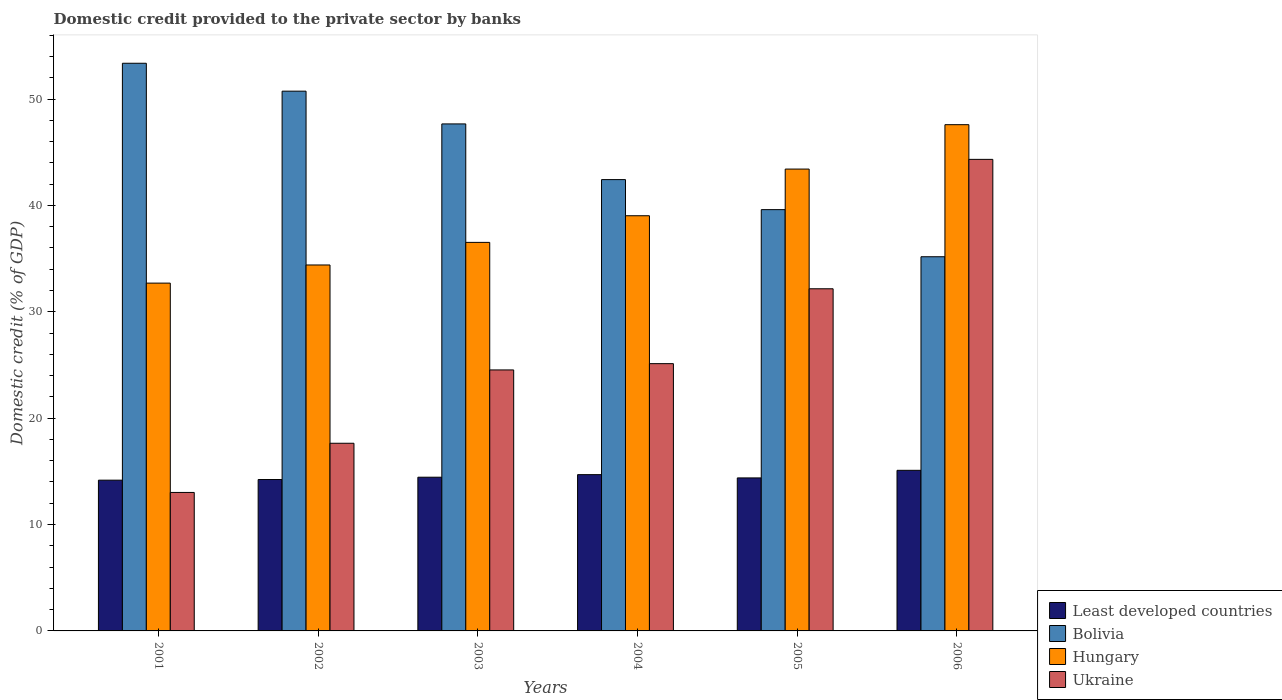How many different coloured bars are there?
Give a very brief answer. 4. How many groups of bars are there?
Make the answer very short. 6. Are the number of bars on each tick of the X-axis equal?
Ensure brevity in your answer.  Yes. What is the label of the 2nd group of bars from the left?
Make the answer very short. 2002. What is the domestic credit provided to the private sector by banks in Ukraine in 2005?
Provide a succinct answer. 32.16. Across all years, what is the maximum domestic credit provided to the private sector by banks in Hungary?
Offer a very short reply. 47.59. Across all years, what is the minimum domestic credit provided to the private sector by banks in Bolivia?
Your answer should be very brief. 35.17. What is the total domestic credit provided to the private sector by banks in Least developed countries in the graph?
Offer a very short reply. 87.03. What is the difference between the domestic credit provided to the private sector by banks in Ukraine in 2004 and that in 2006?
Provide a short and direct response. -19.2. What is the difference between the domestic credit provided to the private sector by banks in Hungary in 2001 and the domestic credit provided to the private sector by banks in Ukraine in 2006?
Give a very brief answer. -11.63. What is the average domestic credit provided to the private sector by banks in Least developed countries per year?
Provide a short and direct response. 14.5. In the year 2004, what is the difference between the domestic credit provided to the private sector by banks in Least developed countries and domestic credit provided to the private sector by banks in Hungary?
Offer a terse response. -24.34. What is the ratio of the domestic credit provided to the private sector by banks in Ukraine in 2002 to that in 2006?
Your answer should be compact. 0.4. What is the difference between the highest and the second highest domestic credit provided to the private sector by banks in Bolivia?
Keep it short and to the point. 2.62. What is the difference between the highest and the lowest domestic credit provided to the private sector by banks in Least developed countries?
Offer a very short reply. 0.93. In how many years, is the domestic credit provided to the private sector by banks in Least developed countries greater than the average domestic credit provided to the private sector by banks in Least developed countries taken over all years?
Give a very brief answer. 2. Is the sum of the domestic credit provided to the private sector by banks in Hungary in 2001 and 2005 greater than the maximum domestic credit provided to the private sector by banks in Least developed countries across all years?
Your response must be concise. Yes. What does the 1st bar from the right in 2004 represents?
Provide a short and direct response. Ukraine. Are all the bars in the graph horizontal?
Your answer should be compact. No. How many years are there in the graph?
Offer a terse response. 6. What is the difference between two consecutive major ticks on the Y-axis?
Ensure brevity in your answer.  10. Does the graph contain any zero values?
Provide a succinct answer. No. Does the graph contain grids?
Keep it short and to the point. No. How many legend labels are there?
Your answer should be compact. 4. What is the title of the graph?
Make the answer very short. Domestic credit provided to the private sector by banks. Does "Dominica" appear as one of the legend labels in the graph?
Give a very brief answer. No. What is the label or title of the Y-axis?
Your response must be concise. Domestic credit (% of GDP). What is the Domestic credit (% of GDP) in Least developed countries in 2001?
Offer a terse response. 14.17. What is the Domestic credit (% of GDP) of Bolivia in 2001?
Your answer should be compact. 53.36. What is the Domestic credit (% of GDP) of Hungary in 2001?
Keep it short and to the point. 32.7. What is the Domestic credit (% of GDP) of Ukraine in 2001?
Ensure brevity in your answer.  13.02. What is the Domestic credit (% of GDP) in Least developed countries in 2002?
Make the answer very short. 14.23. What is the Domestic credit (% of GDP) in Bolivia in 2002?
Give a very brief answer. 50.74. What is the Domestic credit (% of GDP) of Hungary in 2002?
Your answer should be very brief. 34.4. What is the Domestic credit (% of GDP) in Ukraine in 2002?
Your response must be concise. 17.64. What is the Domestic credit (% of GDP) of Least developed countries in 2003?
Give a very brief answer. 14.45. What is the Domestic credit (% of GDP) in Bolivia in 2003?
Keep it short and to the point. 47.66. What is the Domestic credit (% of GDP) in Hungary in 2003?
Ensure brevity in your answer.  36.52. What is the Domestic credit (% of GDP) in Ukraine in 2003?
Provide a succinct answer. 24.54. What is the Domestic credit (% of GDP) of Least developed countries in 2004?
Offer a terse response. 14.69. What is the Domestic credit (% of GDP) of Bolivia in 2004?
Provide a short and direct response. 42.43. What is the Domestic credit (% of GDP) in Hungary in 2004?
Ensure brevity in your answer.  39.03. What is the Domestic credit (% of GDP) in Ukraine in 2004?
Give a very brief answer. 25.13. What is the Domestic credit (% of GDP) of Least developed countries in 2005?
Your answer should be very brief. 14.38. What is the Domestic credit (% of GDP) in Bolivia in 2005?
Your response must be concise. 39.6. What is the Domestic credit (% of GDP) in Hungary in 2005?
Provide a succinct answer. 43.42. What is the Domestic credit (% of GDP) of Ukraine in 2005?
Provide a short and direct response. 32.16. What is the Domestic credit (% of GDP) in Least developed countries in 2006?
Ensure brevity in your answer.  15.1. What is the Domestic credit (% of GDP) of Bolivia in 2006?
Your response must be concise. 35.17. What is the Domestic credit (% of GDP) of Hungary in 2006?
Offer a terse response. 47.59. What is the Domestic credit (% of GDP) of Ukraine in 2006?
Provide a short and direct response. 44.33. Across all years, what is the maximum Domestic credit (% of GDP) of Least developed countries?
Your answer should be compact. 15.1. Across all years, what is the maximum Domestic credit (% of GDP) of Bolivia?
Provide a succinct answer. 53.36. Across all years, what is the maximum Domestic credit (% of GDP) in Hungary?
Your response must be concise. 47.59. Across all years, what is the maximum Domestic credit (% of GDP) in Ukraine?
Your answer should be compact. 44.33. Across all years, what is the minimum Domestic credit (% of GDP) in Least developed countries?
Your answer should be compact. 14.17. Across all years, what is the minimum Domestic credit (% of GDP) in Bolivia?
Keep it short and to the point. 35.17. Across all years, what is the minimum Domestic credit (% of GDP) of Hungary?
Your answer should be very brief. 32.7. Across all years, what is the minimum Domestic credit (% of GDP) of Ukraine?
Make the answer very short. 13.02. What is the total Domestic credit (% of GDP) of Least developed countries in the graph?
Your answer should be compact. 87.03. What is the total Domestic credit (% of GDP) in Bolivia in the graph?
Offer a terse response. 268.97. What is the total Domestic credit (% of GDP) of Hungary in the graph?
Give a very brief answer. 233.66. What is the total Domestic credit (% of GDP) of Ukraine in the graph?
Your answer should be compact. 156.81. What is the difference between the Domestic credit (% of GDP) in Least developed countries in 2001 and that in 2002?
Make the answer very short. -0.06. What is the difference between the Domestic credit (% of GDP) of Bolivia in 2001 and that in 2002?
Your answer should be very brief. 2.62. What is the difference between the Domestic credit (% of GDP) of Hungary in 2001 and that in 2002?
Your answer should be very brief. -1.71. What is the difference between the Domestic credit (% of GDP) of Ukraine in 2001 and that in 2002?
Keep it short and to the point. -4.62. What is the difference between the Domestic credit (% of GDP) of Least developed countries in 2001 and that in 2003?
Provide a short and direct response. -0.28. What is the difference between the Domestic credit (% of GDP) in Bolivia in 2001 and that in 2003?
Offer a very short reply. 5.7. What is the difference between the Domestic credit (% of GDP) of Hungary in 2001 and that in 2003?
Provide a short and direct response. -3.83. What is the difference between the Domestic credit (% of GDP) of Ukraine in 2001 and that in 2003?
Provide a succinct answer. -11.52. What is the difference between the Domestic credit (% of GDP) in Least developed countries in 2001 and that in 2004?
Provide a succinct answer. -0.52. What is the difference between the Domestic credit (% of GDP) in Bolivia in 2001 and that in 2004?
Provide a short and direct response. 10.94. What is the difference between the Domestic credit (% of GDP) in Hungary in 2001 and that in 2004?
Offer a very short reply. -6.33. What is the difference between the Domestic credit (% of GDP) of Ukraine in 2001 and that in 2004?
Provide a succinct answer. -12.11. What is the difference between the Domestic credit (% of GDP) of Least developed countries in 2001 and that in 2005?
Provide a succinct answer. -0.21. What is the difference between the Domestic credit (% of GDP) of Bolivia in 2001 and that in 2005?
Give a very brief answer. 13.76. What is the difference between the Domestic credit (% of GDP) of Hungary in 2001 and that in 2005?
Your response must be concise. -10.72. What is the difference between the Domestic credit (% of GDP) in Ukraine in 2001 and that in 2005?
Offer a terse response. -19.15. What is the difference between the Domestic credit (% of GDP) of Least developed countries in 2001 and that in 2006?
Ensure brevity in your answer.  -0.93. What is the difference between the Domestic credit (% of GDP) in Bolivia in 2001 and that in 2006?
Give a very brief answer. 18.19. What is the difference between the Domestic credit (% of GDP) in Hungary in 2001 and that in 2006?
Offer a very short reply. -14.89. What is the difference between the Domestic credit (% of GDP) in Ukraine in 2001 and that in 2006?
Your answer should be compact. -31.31. What is the difference between the Domestic credit (% of GDP) of Least developed countries in 2002 and that in 2003?
Ensure brevity in your answer.  -0.22. What is the difference between the Domestic credit (% of GDP) of Bolivia in 2002 and that in 2003?
Provide a succinct answer. 3.08. What is the difference between the Domestic credit (% of GDP) of Hungary in 2002 and that in 2003?
Ensure brevity in your answer.  -2.12. What is the difference between the Domestic credit (% of GDP) of Ukraine in 2002 and that in 2003?
Your answer should be very brief. -6.89. What is the difference between the Domestic credit (% of GDP) in Least developed countries in 2002 and that in 2004?
Keep it short and to the point. -0.46. What is the difference between the Domestic credit (% of GDP) in Bolivia in 2002 and that in 2004?
Your answer should be very brief. 8.31. What is the difference between the Domestic credit (% of GDP) of Hungary in 2002 and that in 2004?
Provide a short and direct response. -4.63. What is the difference between the Domestic credit (% of GDP) in Ukraine in 2002 and that in 2004?
Give a very brief answer. -7.48. What is the difference between the Domestic credit (% of GDP) in Least developed countries in 2002 and that in 2005?
Keep it short and to the point. -0.15. What is the difference between the Domestic credit (% of GDP) in Bolivia in 2002 and that in 2005?
Give a very brief answer. 11.14. What is the difference between the Domestic credit (% of GDP) of Hungary in 2002 and that in 2005?
Make the answer very short. -9.02. What is the difference between the Domestic credit (% of GDP) in Ukraine in 2002 and that in 2005?
Your answer should be very brief. -14.52. What is the difference between the Domestic credit (% of GDP) of Least developed countries in 2002 and that in 2006?
Offer a very short reply. -0.86. What is the difference between the Domestic credit (% of GDP) in Bolivia in 2002 and that in 2006?
Provide a short and direct response. 15.57. What is the difference between the Domestic credit (% of GDP) of Hungary in 2002 and that in 2006?
Provide a succinct answer. -13.19. What is the difference between the Domestic credit (% of GDP) in Ukraine in 2002 and that in 2006?
Give a very brief answer. -26.69. What is the difference between the Domestic credit (% of GDP) in Least developed countries in 2003 and that in 2004?
Provide a short and direct response. -0.24. What is the difference between the Domestic credit (% of GDP) of Bolivia in 2003 and that in 2004?
Provide a succinct answer. 5.23. What is the difference between the Domestic credit (% of GDP) of Hungary in 2003 and that in 2004?
Ensure brevity in your answer.  -2.5. What is the difference between the Domestic credit (% of GDP) in Ukraine in 2003 and that in 2004?
Provide a short and direct response. -0.59. What is the difference between the Domestic credit (% of GDP) of Least developed countries in 2003 and that in 2005?
Make the answer very short. 0.07. What is the difference between the Domestic credit (% of GDP) in Bolivia in 2003 and that in 2005?
Keep it short and to the point. 8.06. What is the difference between the Domestic credit (% of GDP) in Hungary in 2003 and that in 2005?
Offer a terse response. -6.89. What is the difference between the Domestic credit (% of GDP) of Ukraine in 2003 and that in 2005?
Keep it short and to the point. -7.63. What is the difference between the Domestic credit (% of GDP) in Least developed countries in 2003 and that in 2006?
Offer a terse response. -0.65. What is the difference between the Domestic credit (% of GDP) of Bolivia in 2003 and that in 2006?
Your answer should be compact. 12.49. What is the difference between the Domestic credit (% of GDP) of Hungary in 2003 and that in 2006?
Offer a terse response. -11.07. What is the difference between the Domestic credit (% of GDP) of Ukraine in 2003 and that in 2006?
Give a very brief answer. -19.79. What is the difference between the Domestic credit (% of GDP) of Least developed countries in 2004 and that in 2005?
Make the answer very short. 0.31. What is the difference between the Domestic credit (% of GDP) of Bolivia in 2004 and that in 2005?
Offer a terse response. 2.82. What is the difference between the Domestic credit (% of GDP) in Hungary in 2004 and that in 2005?
Provide a succinct answer. -4.39. What is the difference between the Domestic credit (% of GDP) in Ukraine in 2004 and that in 2005?
Your answer should be very brief. -7.04. What is the difference between the Domestic credit (% of GDP) of Least developed countries in 2004 and that in 2006?
Provide a short and direct response. -0.41. What is the difference between the Domestic credit (% of GDP) in Bolivia in 2004 and that in 2006?
Offer a very short reply. 7.25. What is the difference between the Domestic credit (% of GDP) in Hungary in 2004 and that in 2006?
Provide a succinct answer. -8.56. What is the difference between the Domestic credit (% of GDP) of Ukraine in 2004 and that in 2006?
Your response must be concise. -19.2. What is the difference between the Domestic credit (% of GDP) in Least developed countries in 2005 and that in 2006?
Your answer should be compact. -0.71. What is the difference between the Domestic credit (% of GDP) of Bolivia in 2005 and that in 2006?
Ensure brevity in your answer.  4.43. What is the difference between the Domestic credit (% of GDP) of Hungary in 2005 and that in 2006?
Provide a succinct answer. -4.17. What is the difference between the Domestic credit (% of GDP) in Ukraine in 2005 and that in 2006?
Ensure brevity in your answer.  -12.17. What is the difference between the Domestic credit (% of GDP) of Least developed countries in 2001 and the Domestic credit (% of GDP) of Bolivia in 2002?
Give a very brief answer. -36.57. What is the difference between the Domestic credit (% of GDP) of Least developed countries in 2001 and the Domestic credit (% of GDP) of Hungary in 2002?
Offer a terse response. -20.23. What is the difference between the Domestic credit (% of GDP) in Least developed countries in 2001 and the Domestic credit (% of GDP) in Ukraine in 2002?
Your answer should be very brief. -3.47. What is the difference between the Domestic credit (% of GDP) of Bolivia in 2001 and the Domestic credit (% of GDP) of Hungary in 2002?
Offer a terse response. 18.96. What is the difference between the Domestic credit (% of GDP) in Bolivia in 2001 and the Domestic credit (% of GDP) in Ukraine in 2002?
Provide a short and direct response. 35.72. What is the difference between the Domestic credit (% of GDP) in Hungary in 2001 and the Domestic credit (% of GDP) in Ukraine in 2002?
Keep it short and to the point. 15.05. What is the difference between the Domestic credit (% of GDP) of Least developed countries in 2001 and the Domestic credit (% of GDP) of Bolivia in 2003?
Your answer should be very brief. -33.49. What is the difference between the Domestic credit (% of GDP) of Least developed countries in 2001 and the Domestic credit (% of GDP) of Hungary in 2003?
Provide a succinct answer. -22.35. What is the difference between the Domestic credit (% of GDP) in Least developed countries in 2001 and the Domestic credit (% of GDP) in Ukraine in 2003?
Offer a very short reply. -10.36. What is the difference between the Domestic credit (% of GDP) of Bolivia in 2001 and the Domestic credit (% of GDP) of Hungary in 2003?
Your answer should be very brief. 16.84. What is the difference between the Domestic credit (% of GDP) of Bolivia in 2001 and the Domestic credit (% of GDP) of Ukraine in 2003?
Provide a short and direct response. 28.83. What is the difference between the Domestic credit (% of GDP) of Hungary in 2001 and the Domestic credit (% of GDP) of Ukraine in 2003?
Your answer should be compact. 8.16. What is the difference between the Domestic credit (% of GDP) of Least developed countries in 2001 and the Domestic credit (% of GDP) of Bolivia in 2004?
Ensure brevity in your answer.  -28.26. What is the difference between the Domestic credit (% of GDP) of Least developed countries in 2001 and the Domestic credit (% of GDP) of Hungary in 2004?
Ensure brevity in your answer.  -24.86. What is the difference between the Domestic credit (% of GDP) in Least developed countries in 2001 and the Domestic credit (% of GDP) in Ukraine in 2004?
Your answer should be very brief. -10.95. What is the difference between the Domestic credit (% of GDP) in Bolivia in 2001 and the Domestic credit (% of GDP) in Hungary in 2004?
Give a very brief answer. 14.33. What is the difference between the Domestic credit (% of GDP) in Bolivia in 2001 and the Domestic credit (% of GDP) in Ukraine in 2004?
Your answer should be compact. 28.24. What is the difference between the Domestic credit (% of GDP) in Hungary in 2001 and the Domestic credit (% of GDP) in Ukraine in 2004?
Ensure brevity in your answer.  7.57. What is the difference between the Domestic credit (% of GDP) in Least developed countries in 2001 and the Domestic credit (% of GDP) in Bolivia in 2005?
Your answer should be compact. -25.43. What is the difference between the Domestic credit (% of GDP) in Least developed countries in 2001 and the Domestic credit (% of GDP) in Hungary in 2005?
Provide a succinct answer. -29.25. What is the difference between the Domestic credit (% of GDP) in Least developed countries in 2001 and the Domestic credit (% of GDP) in Ukraine in 2005?
Offer a terse response. -17.99. What is the difference between the Domestic credit (% of GDP) of Bolivia in 2001 and the Domestic credit (% of GDP) of Hungary in 2005?
Offer a very short reply. 9.95. What is the difference between the Domestic credit (% of GDP) of Bolivia in 2001 and the Domestic credit (% of GDP) of Ukraine in 2005?
Provide a succinct answer. 21.2. What is the difference between the Domestic credit (% of GDP) of Hungary in 2001 and the Domestic credit (% of GDP) of Ukraine in 2005?
Make the answer very short. 0.53. What is the difference between the Domestic credit (% of GDP) of Least developed countries in 2001 and the Domestic credit (% of GDP) of Bolivia in 2006?
Provide a succinct answer. -21. What is the difference between the Domestic credit (% of GDP) of Least developed countries in 2001 and the Domestic credit (% of GDP) of Hungary in 2006?
Your answer should be very brief. -33.42. What is the difference between the Domestic credit (% of GDP) in Least developed countries in 2001 and the Domestic credit (% of GDP) in Ukraine in 2006?
Provide a short and direct response. -30.16. What is the difference between the Domestic credit (% of GDP) of Bolivia in 2001 and the Domestic credit (% of GDP) of Hungary in 2006?
Your answer should be compact. 5.77. What is the difference between the Domestic credit (% of GDP) of Bolivia in 2001 and the Domestic credit (% of GDP) of Ukraine in 2006?
Give a very brief answer. 9.03. What is the difference between the Domestic credit (% of GDP) of Hungary in 2001 and the Domestic credit (% of GDP) of Ukraine in 2006?
Offer a terse response. -11.63. What is the difference between the Domestic credit (% of GDP) of Least developed countries in 2002 and the Domestic credit (% of GDP) of Bolivia in 2003?
Offer a very short reply. -33.43. What is the difference between the Domestic credit (% of GDP) of Least developed countries in 2002 and the Domestic credit (% of GDP) of Hungary in 2003?
Your response must be concise. -22.29. What is the difference between the Domestic credit (% of GDP) in Least developed countries in 2002 and the Domestic credit (% of GDP) in Ukraine in 2003?
Make the answer very short. -10.3. What is the difference between the Domestic credit (% of GDP) in Bolivia in 2002 and the Domestic credit (% of GDP) in Hungary in 2003?
Keep it short and to the point. 14.22. What is the difference between the Domestic credit (% of GDP) in Bolivia in 2002 and the Domestic credit (% of GDP) in Ukraine in 2003?
Ensure brevity in your answer.  26.2. What is the difference between the Domestic credit (% of GDP) in Hungary in 2002 and the Domestic credit (% of GDP) in Ukraine in 2003?
Make the answer very short. 9.87. What is the difference between the Domestic credit (% of GDP) of Least developed countries in 2002 and the Domestic credit (% of GDP) of Bolivia in 2004?
Your answer should be compact. -28.19. What is the difference between the Domestic credit (% of GDP) in Least developed countries in 2002 and the Domestic credit (% of GDP) in Hungary in 2004?
Keep it short and to the point. -24.8. What is the difference between the Domestic credit (% of GDP) of Least developed countries in 2002 and the Domestic credit (% of GDP) of Ukraine in 2004?
Make the answer very short. -10.89. What is the difference between the Domestic credit (% of GDP) of Bolivia in 2002 and the Domestic credit (% of GDP) of Hungary in 2004?
Your response must be concise. 11.71. What is the difference between the Domestic credit (% of GDP) of Bolivia in 2002 and the Domestic credit (% of GDP) of Ukraine in 2004?
Offer a terse response. 25.61. What is the difference between the Domestic credit (% of GDP) in Hungary in 2002 and the Domestic credit (% of GDP) in Ukraine in 2004?
Ensure brevity in your answer.  9.28. What is the difference between the Domestic credit (% of GDP) in Least developed countries in 2002 and the Domestic credit (% of GDP) in Bolivia in 2005?
Make the answer very short. -25.37. What is the difference between the Domestic credit (% of GDP) of Least developed countries in 2002 and the Domestic credit (% of GDP) of Hungary in 2005?
Provide a short and direct response. -29.18. What is the difference between the Domestic credit (% of GDP) in Least developed countries in 2002 and the Domestic credit (% of GDP) in Ukraine in 2005?
Provide a short and direct response. -17.93. What is the difference between the Domestic credit (% of GDP) of Bolivia in 2002 and the Domestic credit (% of GDP) of Hungary in 2005?
Make the answer very short. 7.32. What is the difference between the Domestic credit (% of GDP) of Bolivia in 2002 and the Domestic credit (% of GDP) of Ukraine in 2005?
Keep it short and to the point. 18.58. What is the difference between the Domestic credit (% of GDP) in Hungary in 2002 and the Domestic credit (% of GDP) in Ukraine in 2005?
Your answer should be very brief. 2.24. What is the difference between the Domestic credit (% of GDP) of Least developed countries in 2002 and the Domestic credit (% of GDP) of Bolivia in 2006?
Ensure brevity in your answer.  -20.94. What is the difference between the Domestic credit (% of GDP) in Least developed countries in 2002 and the Domestic credit (% of GDP) in Hungary in 2006?
Your response must be concise. -33.36. What is the difference between the Domestic credit (% of GDP) of Least developed countries in 2002 and the Domestic credit (% of GDP) of Ukraine in 2006?
Provide a short and direct response. -30.1. What is the difference between the Domestic credit (% of GDP) of Bolivia in 2002 and the Domestic credit (% of GDP) of Hungary in 2006?
Offer a terse response. 3.15. What is the difference between the Domestic credit (% of GDP) of Bolivia in 2002 and the Domestic credit (% of GDP) of Ukraine in 2006?
Provide a succinct answer. 6.41. What is the difference between the Domestic credit (% of GDP) of Hungary in 2002 and the Domestic credit (% of GDP) of Ukraine in 2006?
Your response must be concise. -9.93. What is the difference between the Domestic credit (% of GDP) of Least developed countries in 2003 and the Domestic credit (% of GDP) of Bolivia in 2004?
Provide a succinct answer. -27.98. What is the difference between the Domestic credit (% of GDP) of Least developed countries in 2003 and the Domestic credit (% of GDP) of Hungary in 2004?
Give a very brief answer. -24.58. What is the difference between the Domestic credit (% of GDP) of Least developed countries in 2003 and the Domestic credit (% of GDP) of Ukraine in 2004?
Provide a succinct answer. -10.68. What is the difference between the Domestic credit (% of GDP) of Bolivia in 2003 and the Domestic credit (% of GDP) of Hungary in 2004?
Your answer should be compact. 8.63. What is the difference between the Domestic credit (% of GDP) in Bolivia in 2003 and the Domestic credit (% of GDP) in Ukraine in 2004?
Provide a succinct answer. 22.54. What is the difference between the Domestic credit (% of GDP) of Hungary in 2003 and the Domestic credit (% of GDP) of Ukraine in 2004?
Your response must be concise. 11.4. What is the difference between the Domestic credit (% of GDP) of Least developed countries in 2003 and the Domestic credit (% of GDP) of Bolivia in 2005?
Ensure brevity in your answer.  -25.15. What is the difference between the Domestic credit (% of GDP) in Least developed countries in 2003 and the Domestic credit (% of GDP) in Hungary in 2005?
Ensure brevity in your answer.  -28.97. What is the difference between the Domestic credit (% of GDP) in Least developed countries in 2003 and the Domestic credit (% of GDP) in Ukraine in 2005?
Offer a terse response. -17.71. What is the difference between the Domestic credit (% of GDP) of Bolivia in 2003 and the Domestic credit (% of GDP) of Hungary in 2005?
Your answer should be compact. 4.24. What is the difference between the Domestic credit (% of GDP) in Bolivia in 2003 and the Domestic credit (% of GDP) in Ukraine in 2005?
Provide a succinct answer. 15.5. What is the difference between the Domestic credit (% of GDP) in Hungary in 2003 and the Domestic credit (% of GDP) in Ukraine in 2005?
Ensure brevity in your answer.  4.36. What is the difference between the Domestic credit (% of GDP) of Least developed countries in 2003 and the Domestic credit (% of GDP) of Bolivia in 2006?
Offer a terse response. -20.72. What is the difference between the Domestic credit (% of GDP) of Least developed countries in 2003 and the Domestic credit (% of GDP) of Hungary in 2006?
Your response must be concise. -33.14. What is the difference between the Domestic credit (% of GDP) in Least developed countries in 2003 and the Domestic credit (% of GDP) in Ukraine in 2006?
Offer a terse response. -29.88. What is the difference between the Domestic credit (% of GDP) in Bolivia in 2003 and the Domestic credit (% of GDP) in Hungary in 2006?
Make the answer very short. 0.07. What is the difference between the Domestic credit (% of GDP) of Bolivia in 2003 and the Domestic credit (% of GDP) of Ukraine in 2006?
Your answer should be very brief. 3.33. What is the difference between the Domestic credit (% of GDP) of Hungary in 2003 and the Domestic credit (% of GDP) of Ukraine in 2006?
Ensure brevity in your answer.  -7.8. What is the difference between the Domestic credit (% of GDP) in Least developed countries in 2004 and the Domestic credit (% of GDP) in Bolivia in 2005?
Your answer should be compact. -24.91. What is the difference between the Domestic credit (% of GDP) in Least developed countries in 2004 and the Domestic credit (% of GDP) in Hungary in 2005?
Give a very brief answer. -28.73. What is the difference between the Domestic credit (% of GDP) in Least developed countries in 2004 and the Domestic credit (% of GDP) in Ukraine in 2005?
Provide a short and direct response. -17.47. What is the difference between the Domestic credit (% of GDP) of Bolivia in 2004 and the Domestic credit (% of GDP) of Hungary in 2005?
Your response must be concise. -0.99. What is the difference between the Domestic credit (% of GDP) of Bolivia in 2004 and the Domestic credit (% of GDP) of Ukraine in 2005?
Provide a succinct answer. 10.26. What is the difference between the Domestic credit (% of GDP) in Hungary in 2004 and the Domestic credit (% of GDP) in Ukraine in 2005?
Give a very brief answer. 6.87. What is the difference between the Domestic credit (% of GDP) of Least developed countries in 2004 and the Domestic credit (% of GDP) of Bolivia in 2006?
Provide a short and direct response. -20.48. What is the difference between the Domestic credit (% of GDP) of Least developed countries in 2004 and the Domestic credit (% of GDP) of Hungary in 2006?
Make the answer very short. -32.9. What is the difference between the Domestic credit (% of GDP) in Least developed countries in 2004 and the Domestic credit (% of GDP) in Ukraine in 2006?
Give a very brief answer. -29.64. What is the difference between the Domestic credit (% of GDP) in Bolivia in 2004 and the Domestic credit (% of GDP) in Hungary in 2006?
Provide a short and direct response. -5.16. What is the difference between the Domestic credit (% of GDP) in Bolivia in 2004 and the Domestic credit (% of GDP) in Ukraine in 2006?
Your answer should be compact. -1.9. What is the difference between the Domestic credit (% of GDP) in Hungary in 2004 and the Domestic credit (% of GDP) in Ukraine in 2006?
Ensure brevity in your answer.  -5.3. What is the difference between the Domestic credit (% of GDP) of Least developed countries in 2005 and the Domestic credit (% of GDP) of Bolivia in 2006?
Offer a terse response. -20.79. What is the difference between the Domestic credit (% of GDP) of Least developed countries in 2005 and the Domestic credit (% of GDP) of Hungary in 2006?
Make the answer very short. -33.21. What is the difference between the Domestic credit (% of GDP) of Least developed countries in 2005 and the Domestic credit (% of GDP) of Ukraine in 2006?
Your answer should be compact. -29.95. What is the difference between the Domestic credit (% of GDP) of Bolivia in 2005 and the Domestic credit (% of GDP) of Hungary in 2006?
Your response must be concise. -7.99. What is the difference between the Domestic credit (% of GDP) in Bolivia in 2005 and the Domestic credit (% of GDP) in Ukraine in 2006?
Keep it short and to the point. -4.73. What is the difference between the Domestic credit (% of GDP) in Hungary in 2005 and the Domestic credit (% of GDP) in Ukraine in 2006?
Offer a terse response. -0.91. What is the average Domestic credit (% of GDP) of Least developed countries per year?
Offer a very short reply. 14.5. What is the average Domestic credit (% of GDP) in Bolivia per year?
Give a very brief answer. 44.83. What is the average Domestic credit (% of GDP) in Hungary per year?
Your response must be concise. 38.94. What is the average Domestic credit (% of GDP) of Ukraine per year?
Offer a very short reply. 26.14. In the year 2001, what is the difference between the Domestic credit (% of GDP) in Least developed countries and Domestic credit (% of GDP) in Bolivia?
Your answer should be very brief. -39.19. In the year 2001, what is the difference between the Domestic credit (% of GDP) in Least developed countries and Domestic credit (% of GDP) in Hungary?
Give a very brief answer. -18.52. In the year 2001, what is the difference between the Domestic credit (% of GDP) in Least developed countries and Domestic credit (% of GDP) in Ukraine?
Ensure brevity in your answer.  1.15. In the year 2001, what is the difference between the Domestic credit (% of GDP) in Bolivia and Domestic credit (% of GDP) in Hungary?
Make the answer very short. 20.67. In the year 2001, what is the difference between the Domestic credit (% of GDP) in Bolivia and Domestic credit (% of GDP) in Ukraine?
Your answer should be very brief. 40.35. In the year 2001, what is the difference between the Domestic credit (% of GDP) of Hungary and Domestic credit (% of GDP) of Ukraine?
Your answer should be compact. 19.68. In the year 2002, what is the difference between the Domestic credit (% of GDP) in Least developed countries and Domestic credit (% of GDP) in Bolivia?
Give a very brief answer. -36.51. In the year 2002, what is the difference between the Domestic credit (% of GDP) in Least developed countries and Domestic credit (% of GDP) in Hungary?
Your answer should be very brief. -20.17. In the year 2002, what is the difference between the Domestic credit (% of GDP) of Least developed countries and Domestic credit (% of GDP) of Ukraine?
Your response must be concise. -3.41. In the year 2002, what is the difference between the Domestic credit (% of GDP) of Bolivia and Domestic credit (% of GDP) of Hungary?
Provide a succinct answer. 16.34. In the year 2002, what is the difference between the Domestic credit (% of GDP) of Bolivia and Domestic credit (% of GDP) of Ukraine?
Keep it short and to the point. 33.1. In the year 2002, what is the difference between the Domestic credit (% of GDP) of Hungary and Domestic credit (% of GDP) of Ukraine?
Provide a short and direct response. 16.76. In the year 2003, what is the difference between the Domestic credit (% of GDP) of Least developed countries and Domestic credit (% of GDP) of Bolivia?
Give a very brief answer. -33.21. In the year 2003, what is the difference between the Domestic credit (% of GDP) of Least developed countries and Domestic credit (% of GDP) of Hungary?
Keep it short and to the point. -22.07. In the year 2003, what is the difference between the Domestic credit (% of GDP) of Least developed countries and Domestic credit (% of GDP) of Ukraine?
Give a very brief answer. -10.09. In the year 2003, what is the difference between the Domestic credit (% of GDP) in Bolivia and Domestic credit (% of GDP) in Hungary?
Provide a succinct answer. 11.14. In the year 2003, what is the difference between the Domestic credit (% of GDP) in Bolivia and Domestic credit (% of GDP) in Ukraine?
Your response must be concise. 23.13. In the year 2003, what is the difference between the Domestic credit (% of GDP) of Hungary and Domestic credit (% of GDP) of Ukraine?
Your answer should be compact. 11.99. In the year 2004, what is the difference between the Domestic credit (% of GDP) in Least developed countries and Domestic credit (% of GDP) in Bolivia?
Your answer should be compact. -27.74. In the year 2004, what is the difference between the Domestic credit (% of GDP) in Least developed countries and Domestic credit (% of GDP) in Hungary?
Give a very brief answer. -24.34. In the year 2004, what is the difference between the Domestic credit (% of GDP) in Least developed countries and Domestic credit (% of GDP) in Ukraine?
Give a very brief answer. -10.43. In the year 2004, what is the difference between the Domestic credit (% of GDP) in Bolivia and Domestic credit (% of GDP) in Hungary?
Provide a short and direct response. 3.4. In the year 2004, what is the difference between the Domestic credit (% of GDP) in Bolivia and Domestic credit (% of GDP) in Ukraine?
Your response must be concise. 17.3. In the year 2004, what is the difference between the Domestic credit (% of GDP) of Hungary and Domestic credit (% of GDP) of Ukraine?
Ensure brevity in your answer.  13.9. In the year 2005, what is the difference between the Domestic credit (% of GDP) of Least developed countries and Domestic credit (% of GDP) of Bolivia?
Your response must be concise. -25.22. In the year 2005, what is the difference between the Domestic credit (% of GDP) of Least developed countries and Domestic credit (% of GDP) of Hungary?
Your answer should be very brief. -29.03. In the year 2005, what is the difference between the Domestic credit (% of GDP) in Least developed countries and Domestic credit (% of GDP) in Ukraine?
Your response must be concise. -17.78. In the year 2005, what is the difference between the Domestic credit (% of GDP) in Bolivia and Domestic credit (% of GDP) in Hungary?
Make the answer very short. -3.81. In the year 2005, what is the difference between the Domestic credit (% of GDP) of Bolivia and Domestic credit (% of GDP) of Ukraine?
Your answer should be compact. 7.44. In the year 2005, what is the difference between the Domestic credit (% of GDP) in Hungary and Domestic credit (% of GDP) in Ukraine?
Provide a succinct answer. 11.25. In the year 2006, what is the difference between the Domestic credit (% of GDP) of Least developed countries and Domestic credit (% of GDP) of Bolivia?
Offer a terse response. -20.08. In the year 2006, what is the difference between the Domestic credit (% of GDP) in Least developed countries and Domestic credit (% of GDP) in Hungary?
Give a very brief answer. -32.49. In the year 2006, what is the difference between the Domestic credit (% of GDP) in Least developed countries and Domestic credit (% of GDP) in Ukraine?
Provide a succinct answer. -29.23. In the year 2006, what is the difference between the Domestic credit (% of GDP) of Bolivia and Domestic credit (% of GDP) of Hungary?
Make the answer very short. -12.41. In the year 2006, what is the difference between the Domestic credit (% of GDP) of Bolivia and Domestic credit (% of GDP) of Ukraine?
Give a very brief answer. -9.15. In the year 2006, what is the difference between the Domestic credit (% of GDP) of Hungary and Domestic credit (% of GDP) of Ukraine?
Your answer should be compact. 3.26. What is the ratio of the Domestic credit (% of GDP) in Bolivia in 2001 to that in 2002?
Provide a short and direct response. 1.05. What is the ratio of the Domestic credit (% of GDP) of Hungary in 2001 to that in 2002?
Ensure brevity in your answer.  0.95. What is the ratio of the Domestic credit (% of GDP) of Ukraine in 2001 to that in 2002?
Ensure brevity in your answer.  0.74. What is the ratio of the Domestic credit (% of GDP) in Least developed countries in 2001 to that in 2003?
Keep it short and to the point. 0.98. What is the ratio of the Domestic credit (% of GDP) in Bolivia in 2001 to that in 2003?
Keep it short and to the point. 1.12. What is the ratio of the Domestic credit (% of GDP) in Hungary in 2001 to that in 2003?
Provide a short and direct response. 0.9. What is the ratio of the Domestic credit (% of GDP) of Ukraine in 2001 to that in 2003?
Your answer should be very brief. 0.53. What is the ratio of the Domestic credit (% of GDP) of Least developed countries in 2001 to that in 2004?
Keep it short and to the point. 0.96. What is the ratio of the Domestic credit (% of GDP) of Bolivia in 2001 to that in 2004?
Offer a terse response. 1.26. What is the ratio of the Domestic credit (% of GDP) of Hungary in 2001 to that in 2004?
Offer a very short reply. 0.84. What is the ratio of the Domestic credit (% of GDP) in Ukraine in 2001 to that in 2004?
Offer a terse response. 0.52. What is the ratio of the Domestic credit (% of GDP) in Least developed countries in 2001 to that in 2005?
Ensure brevity in your answer.  0.99. What is the ratio of the Domestic credit (% of GDP) of Bolivia in 2001 to that in 2005?
Give a very brief answer. 1.35. What is the ratio of the Domestic credit (% of GDP) in Hungary in 2001 to that in 2005?
Keep it short and to the point. 0.75. What is the ratio of the Domestic credit (% of GDP) of Ukraine in 2001 to that in 2005?
Your response must be concise. 0.4. What is the ratio of the Domestic credit (% of GDP) of Least developed countries in 2001 to that in 2006?
Offer a terse response. 0.94. What is the ratio of the Domestic credit (% of GDP) in Bolivia in 2001 to that in 2006?
Ensure brevity in your answer.  1.52. What is the ratio of the Domestic credit (% of GDP) in Hungary in 2001 to that in 2006?
Make the answer very short. 0.69. What is the ratio of the Domestic credit (% of GDP) of Ukraine in 2001 to that in 2006?
Ensure brevity in your answer.  0.29. What is the ratio of the Domestic credit (% of GDP) in Least developed countries in 2002 to that in 2003?
Offer a terse response. 0.98. What is the ratio of the Domestic credit (% of GDP) of Bolivia in 2002 to that in 2003?
Your answer should be very brief. 1.06. What is the ratio of the Domestic credit (% of GDP) of Hungary in 2002 to that in 2003?
Provide a short and direct response. 0.94. What is the ratio of the Domestic credit (% of GDP) of Ukraine in 2002 to that in 2003?
Your answer should be very brief. 0.72. What is the ratio of the Domestic credit (% of GDP) of Least developed countries in 2002 to that in 2004?
Your answer should be compact. 0.97. What is the ratio of the Domestic credit (% of GDP) of Bolivia in 2002 to that in 2004?
Ensure brevity in your answer.  1.2. What is the ratio of the Domestic credit (% of GDP) in Hungary in 2002 to that in 2004?
Your response must be concise. 0.88. What is the ratio of the Domestic credit (% of GDP) of Ukraine in 2002 to that in 2004?
Your answer should be compact. 0.7. What is the ratio of the Domestic credit (% of GDP) of Bolivia in 2002 to that in 2005?
Your response must be concise. 1.28. What is the ratio of the Domestic credit (% of GDP) in Hungary in 2002 to that in 2005?
Your response must be concise. 0.79. What is the ratio of the Domestic credit (% of GDP) of Ukraine in 2002 to that in 2005?
Ensure brevity in your answer.  0.55. What is the ratio of the Domestic credit (% of GDP) of Least developed countries in 2002 to that in 2006?
Provide a succinct answer. 0.94. What is the ratio of the Domestic credit (% of GDP) of Bolivia in 2002 to that in 2006?
Provide a succinct answer. 1.44. What is the ratio of the Domestic credit (% of GDP) of Hungary in 2002 to that in 2006?
Your answer should be very brief. 0.72. What is the ratio of the Domestic credit (% of GDP) of Ukraine in 2002 to that in 2006?
Ensure brevity in your answer.  0.4. What is the ratio of the Domestic credit (% of GDP) in Least developed countries in 2003 to that in 2004?
Give a very brief answer. 0.98. What is the ratio of the Domestic credit (% of GDP) in Bolivia in 2003 to that in 2004?
Offer a terse response. 1.12. What is the ratio of the Domestic credit (% of GDP) of Hungary in 2003 to that in 2004?
Provide a short and direct response. 0.94. What is the ratio of the Domestic credit (% of GDP) in Ukraine in 2003 to that in 2004?
Your answer should be very brief. 0.98. What is the ratio of the Domestic credit (% of GDP) in Bolivia in 2003 to that in 2005?
Offer a terse response. 1.2. What is the ratio of the Domestic credit (% of GDP) of Hungary in 2003 to that in 2005?
Give a very brief answer. 0.84. What is the ratio of the Domestic credit (% of GDP) in Ukraine in 2003 to that in 2005?
Offer a terse response. 0.76. What is the ratio of the Domestic credit (% of GDP) in Least developed countries in 2003 to that in 2006?
Your response must be concise. 0.96. What is the ratio of the Domestic credit (% of GDP) of Bolivia in 2003 to that in 2006?
Your answer should be very brief. 1.35. What is the ratio of the Domestic credit (% of GDP) in Hungary in 2003 to that in 2006?
Keep it short and to the point. 0.77. What is the ratio of the Domestic credit (% of GDP) in Ukraine in 2003 to that in 2006?
Offer a very short reply. 0.55. What is the ratio of the Domestic credit (% of GDP) of Least developed countries in 2004 to that in 2005?
Offer a terse response. 1.02. What is the ratio of the Domestic credit (% of GDP) in Bolivia in 2004 to that in 2005?
Offer a terse response. 1.07. What is the ratio of the Domestic credit (% of GDP) in Hungary in 2004 to that in 2005?
Provide a short and direct response. 0.9. What is the ratio of the Domestic credit (% of GDP) of Ukraine in 2004 to that in 2005?
Give a very brief answer. 0.78. What is the ratio of the Domestic credit (% of GDP) of Least developed countries in 2004 to that in 2006?
Make the answer very short. 0.97. What is the ratio of the Domestic credit (% of GDP) of Bolivia in 2004 to that in 2006?
Keep it short and to the point. 1.21. What is the ratio of the Domestic credit (% of GDP) in Hungary in 2004 to that in 2006?
Offer a very short reply. 0.82. What is the ratio of the Domestic credit (% of GDP) in Ukraine in 2004 to that in 2006?
Keep it short and to the point. 0.57. What is the ratio of the Domestic credit (% of GDP) in Least developed countries in 2005 to that in 2006?
Your answer should be compact. 0.95. What is the ratio of the Domestic credit (% of GDP) in Bolivia in 2005 to that in 2006?
Offer a terse response. 1.13. What is the ratio of the Domestic credit (% of GDP) in Hungary in 2005 to that in 2006?
Offer a very short reply. 0.91. What is the ratio of the Domestic credit (% of GDP) in Ukraine in 2005 to that in 2006?
Offer a very short reply. 0.73. What is the difference between the highest and the second highest Domestic credit (% of GDP) of Least developed countries?
Ensure brevity in your answer.  0.41. What is the difference between the highest and the second highest Domestic credit (% of GDP) in Bolivia?
Your answer should be compact. 2.62. What is the difference between the highest and the second highest Domestic credit (% of GDP) of Hungary?
Offer a very short reply. 4.17. What is the difference between the highest and the second highest Domestic credit (% of GDP) in Ukraine?
Provide a short and direct response. 12.17. What is the difference between the highest and the lowest Domestic credit (% of GDP) in Least developed countries?
Give a very brief answer. 0.93. What is the difference between the highest and the lowest Domestic credit (% of GDP) in Bolivia?
Offer a terse response. 18.19. What is the difference between the highest and the lowest Domestic credit (% of GDP) of Hungary?
Your response must be concise. 14.89. What is the difference between the highest and the lowest Domestic credit (% of GDP) of Ukraine?
Keep it short and to the point. 31.31. 